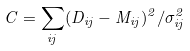<formula> <loc_0><loc_0><loc_500><loc_500>C = \sum _ { i j } ( D _ { i j } - M _ { i j } ) ^ { 2 } / \sigma ^ { 2 } _ { i j }</formula> 